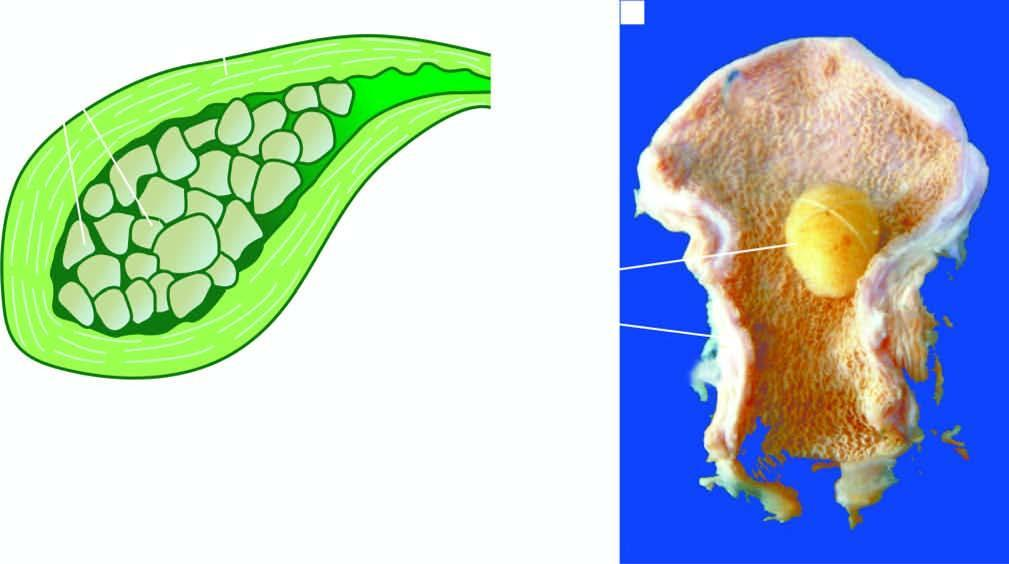s endothelial injury packed with well-fitting, multiple, multi-faceted, mixed gallstones?
Answer the question using a single word or phrase. No 